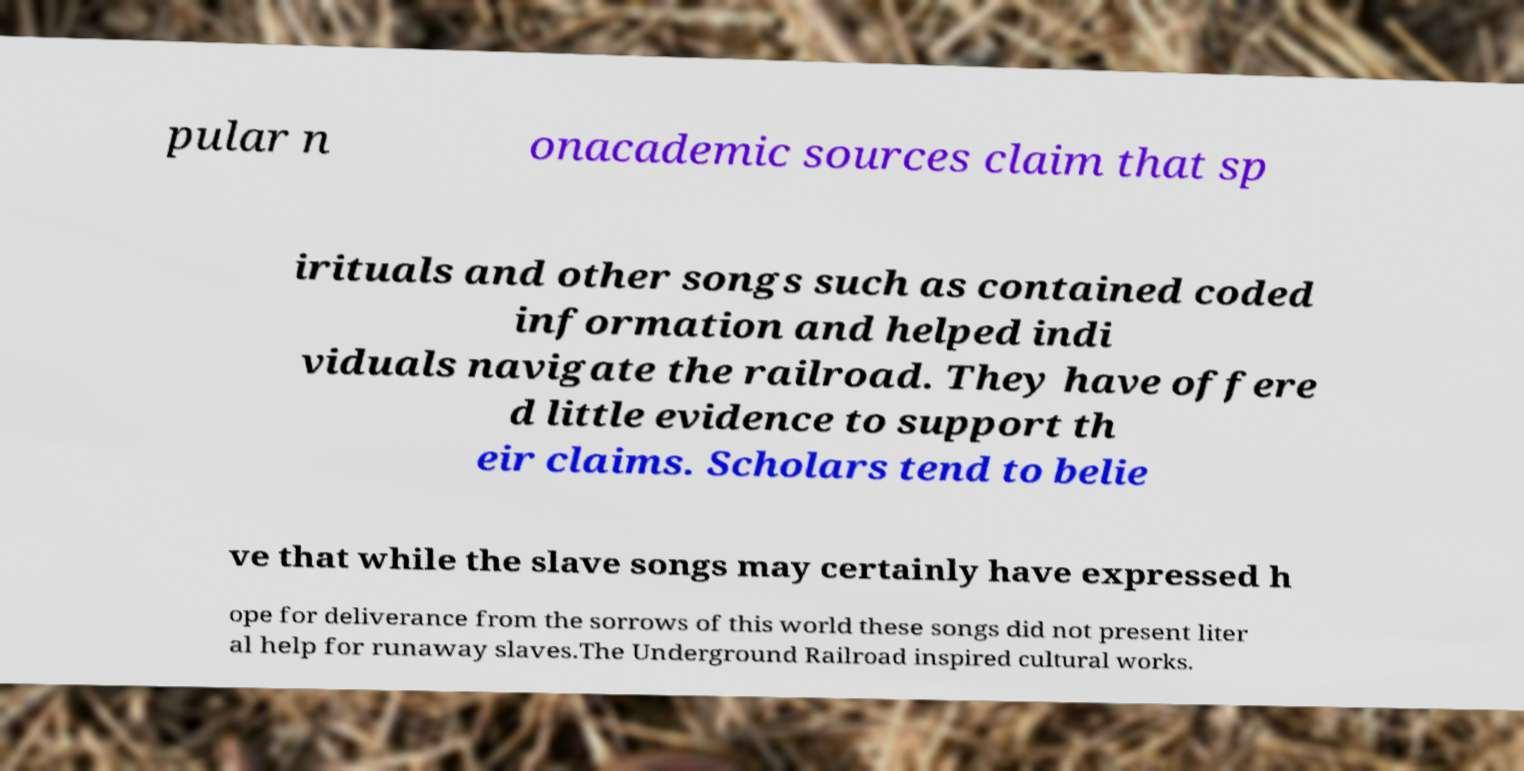Can you read and provide the text displayed in the image?This photo seems to have some interesting text. Can you extract and type it out for me? pular n onacademic sources claim that sp irituals and other songs such as contained coded information and helped indi viduals navigate the railroad. They have offere d little evidence to support th eir claims. Scholars tend to belie ve that while the slave songs may certainly have expressed h ope for deliverance from the sorrows of this world these songs did not present liter al help for runaway slaves.The Underground Railroad inspired cultural works. 